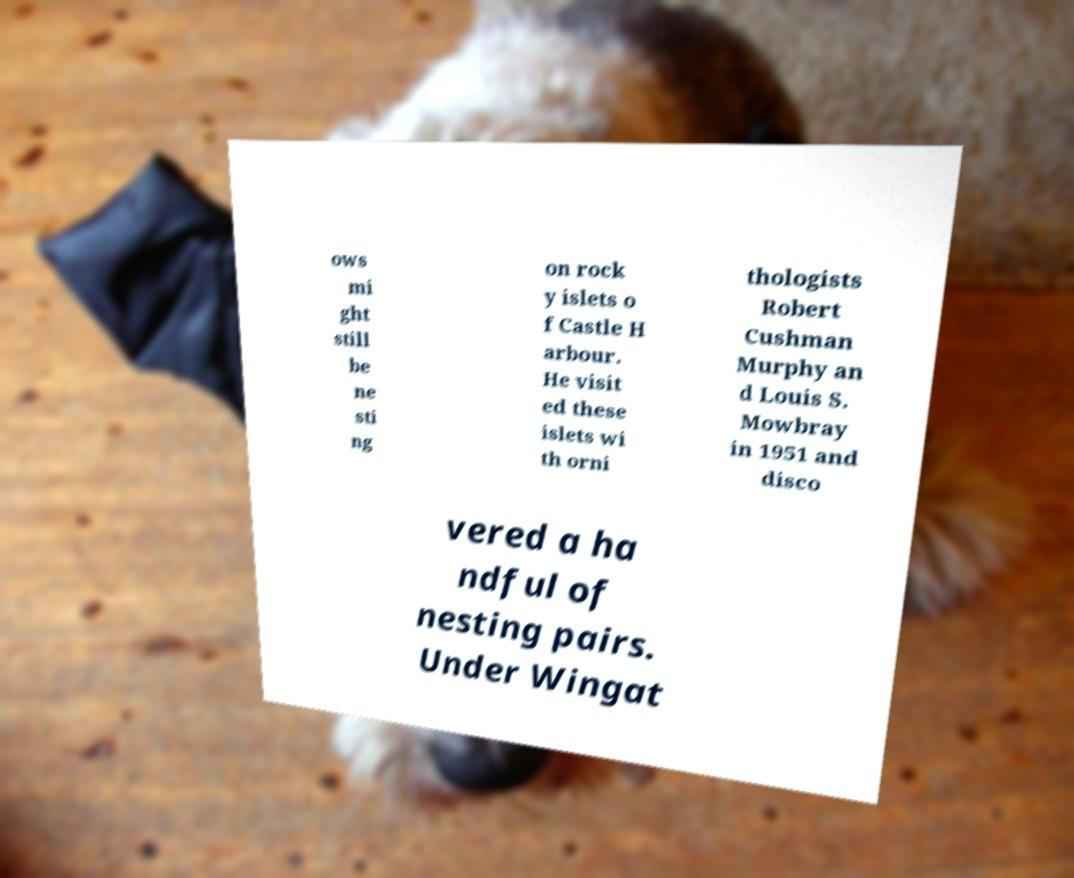I need the written content from this picture converted into text. Can you do that? ows mi ght still be ne sti ng on rock y islets o f Castle H arbour. He visit ed these islets wi th orni thologists Robert Cushman Murphy an d Louis S. Mowbray in 1951 and disco vered a ha ndful of nesting pairs. Under Wingat 